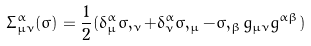<formula> <loc_0><loc_0><loc_500><loc_500>\Sigma ^ { \alpha } _ { \mu \nu } ( \sigma ) = \frac { 1 } { 2 } ( \delta ^ { \alpha } _ { \mu } \sigma , _ { \nu } + \delta ^ { \alpha } _ { \nu } \sigma , _ { \mu } - \sigma , _ { \beta } g _ { \mu \nu } g ^ { \alpha \beta } )</formula> 